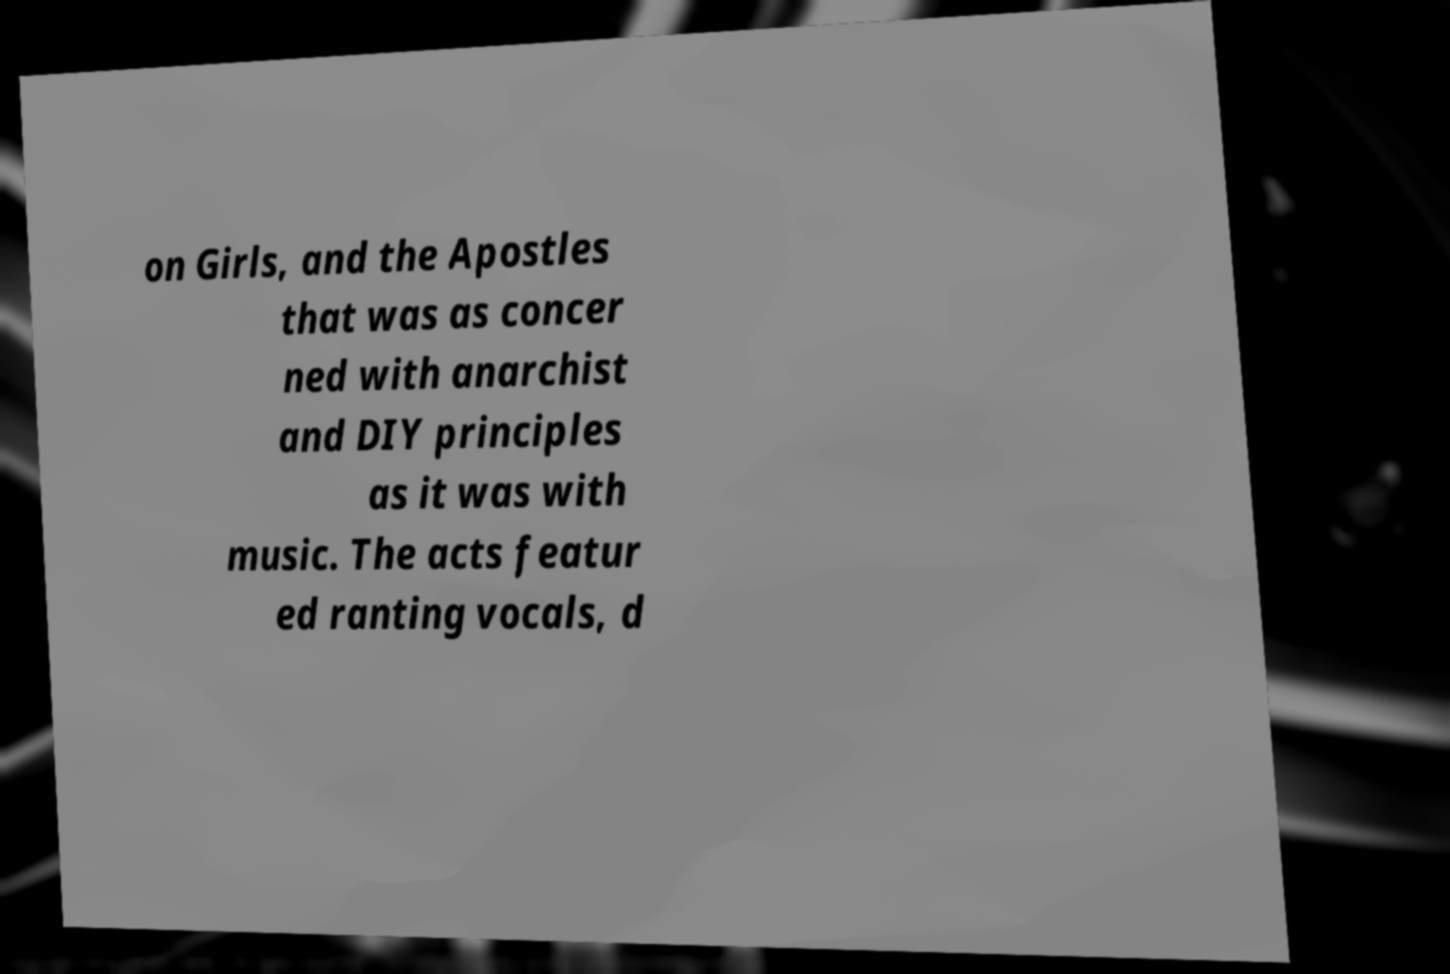Please identify and transcribe the text found in this image. on Girls, and the Apostles that was as concer ned with anarchist and DIY principles as it was with music. The acts featur ed ranting vocals, d 